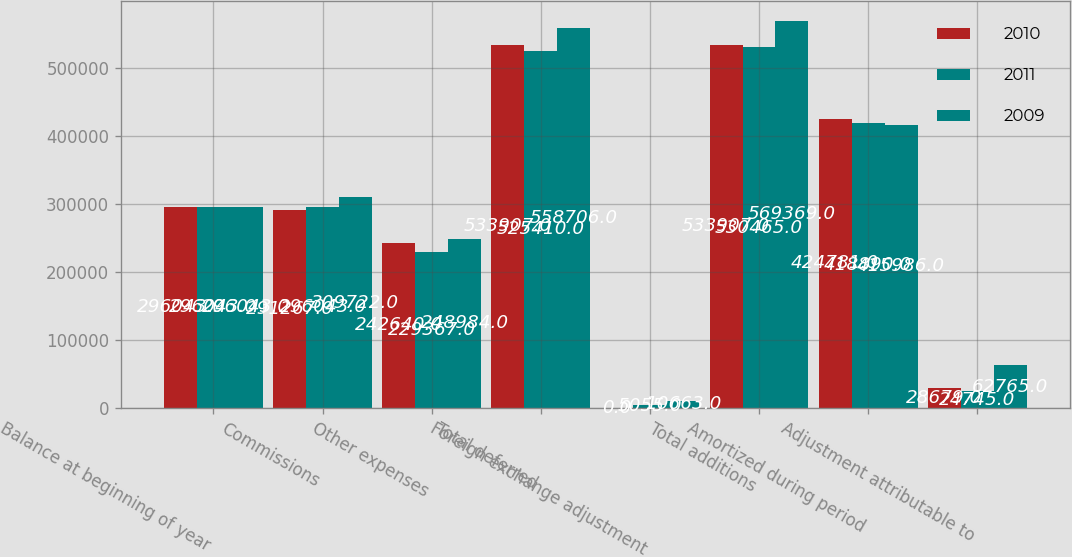Convert chart. <chart><loc_0><loc_0><loc_500><loc_500><stacked_bar_chart><ecel><fcel>Balance at beginning of year<fcel>Commissions<fcel>Other expenses<fcel>Total deferred<fcel>Foreign exchange adjustment<fcel>Total additions<fcel>Amortized during period<fcel>Adjustment attributable to<nl><fcel>2010<fcel>296043<fcel>291267<fcel>242640<fcel>533907<fcel>0<fcel>533907<fcel>424781<fcel>28679<nl><fcel>2011<fcel>296043<fcel>296043<fcel>229367<fcel>525410<fcel>5055<fcel>530465<fcel>418890<fcel>24745<nl><fcel>2009<fcel>296043<fcel>309722<fcel>248984<fcel>558706<fcel>10663<fcel>569369<fcel>415986<fcel>62765<nl></chart> 